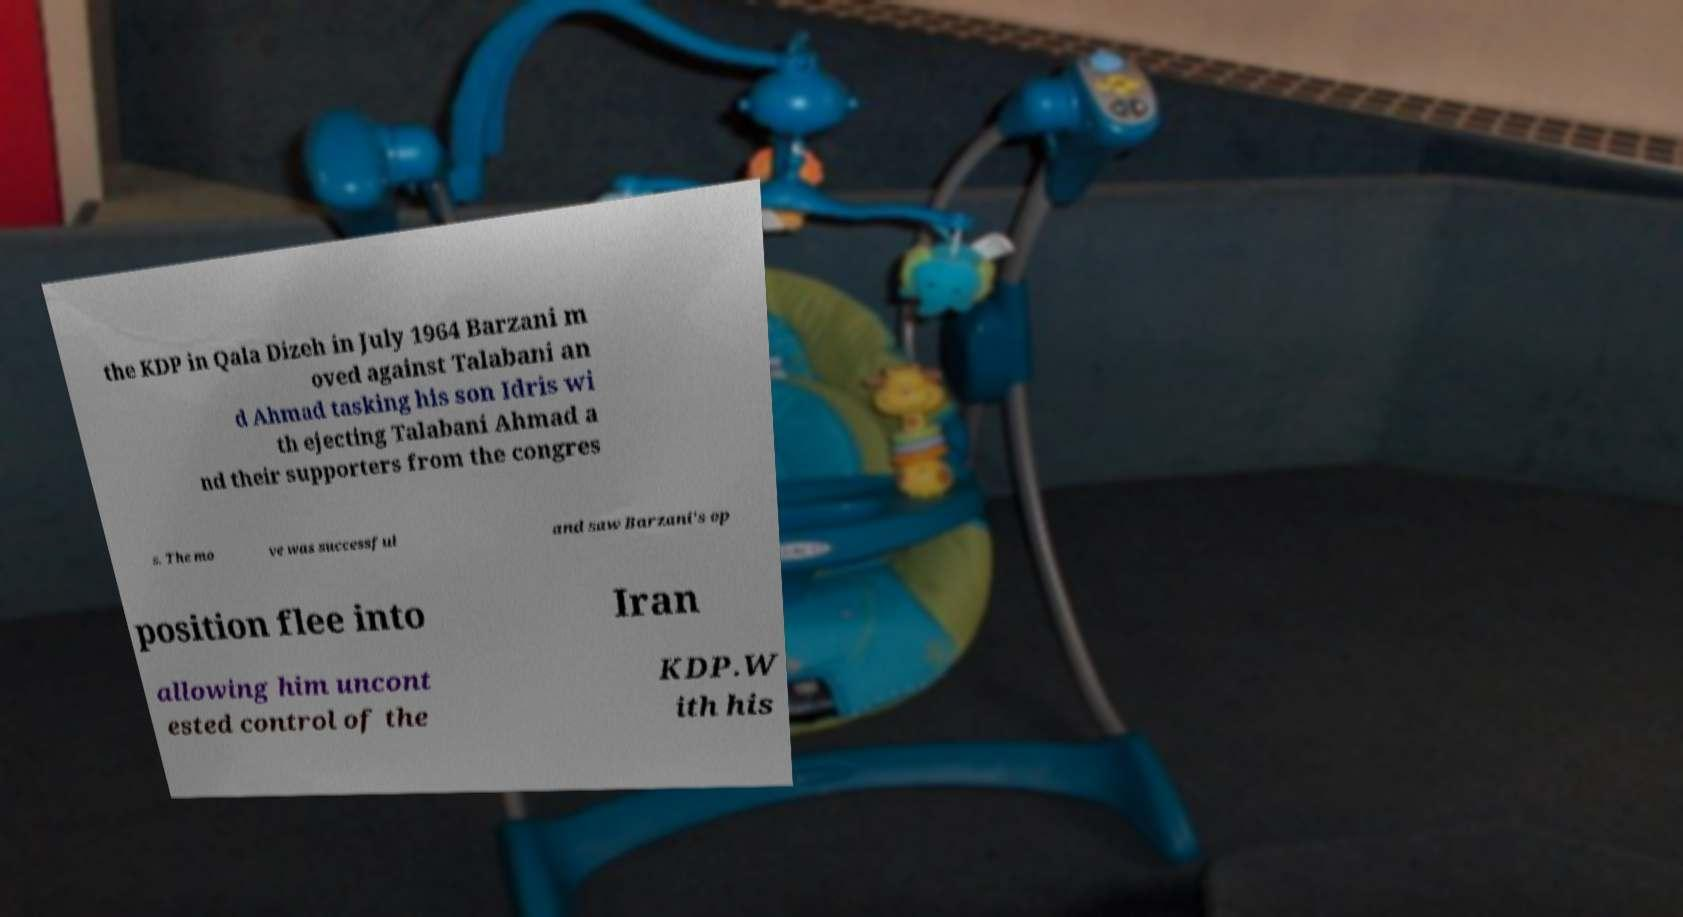Please read and relay the text visible in this image. What does it say? the KDP in Qala Dizeh in July 1964 Barzani m oved against Talabani an d Ahmad tasking his son Idris wi th ejecting Talabani Ahmad a nd their supporters from the congres s. The mo ve was successful and saw Barzani's op position flee into Iran allowing him uncont ested control of the KDP.W ith his 